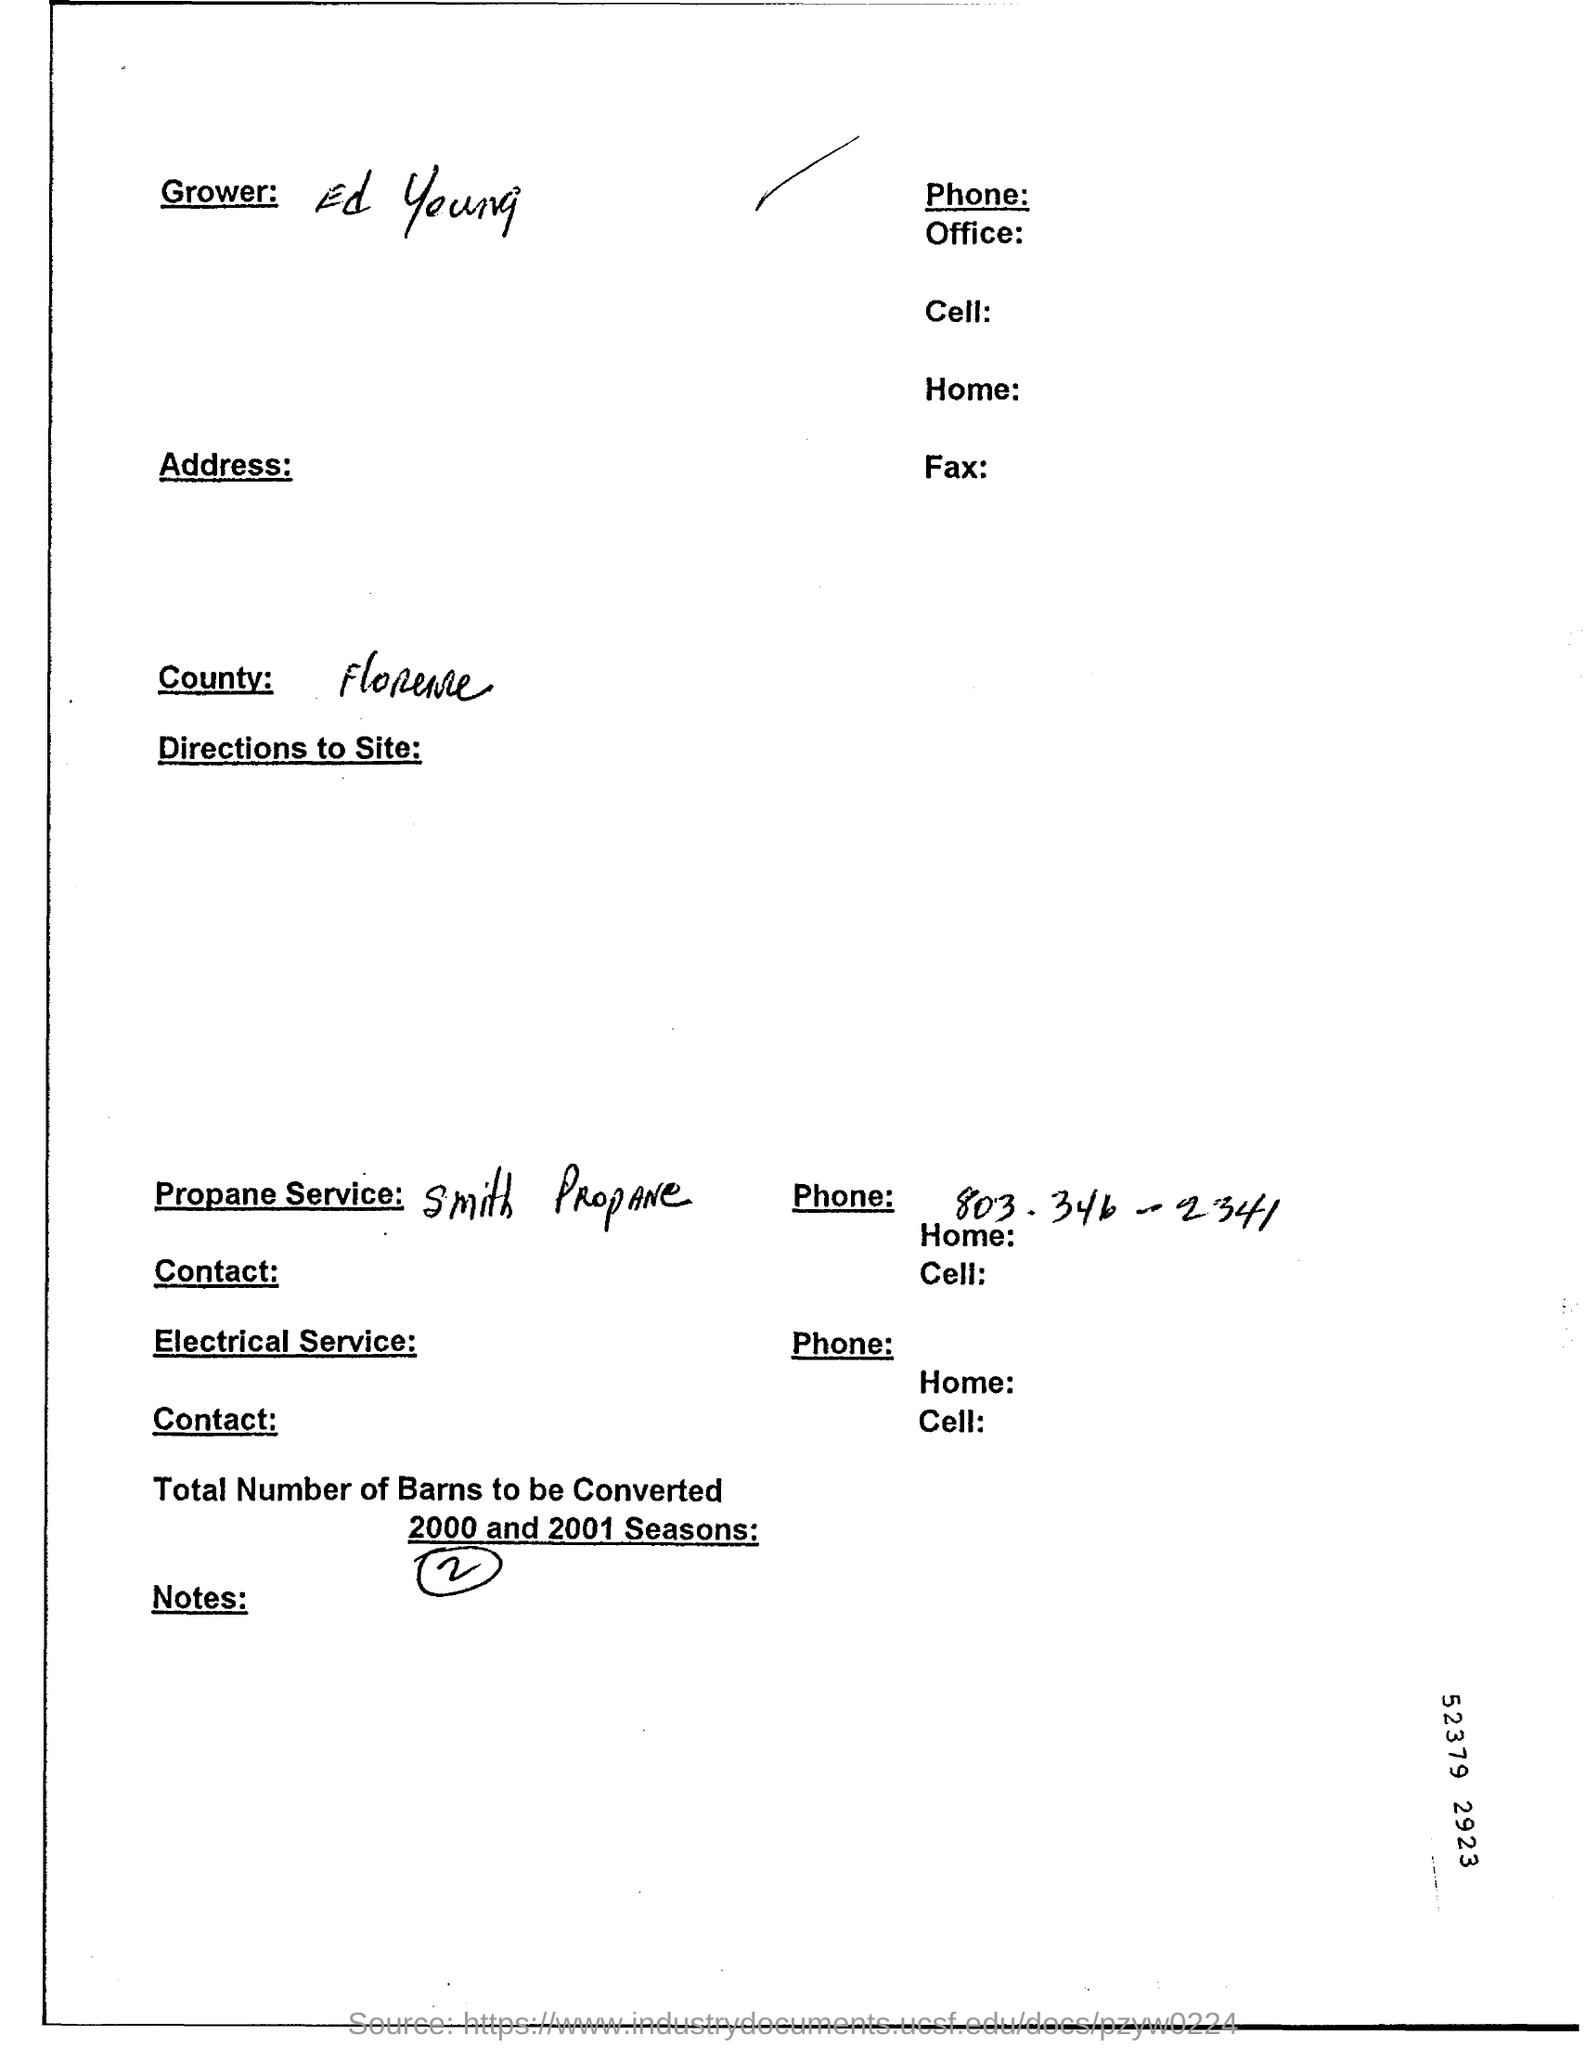Who is the Grower?
Give a very brief answer. Ed Young. 